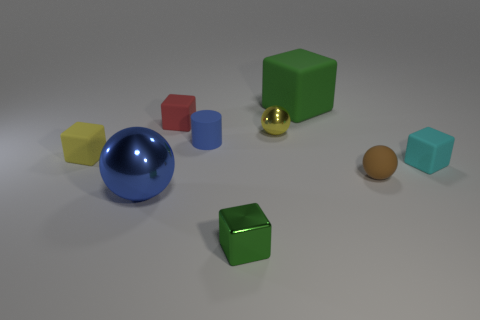What number of cylinders are on the right side of the matte object on the right side of the small brown matte thing?
Ensure brevity in your answer.  0. What number of other things are there of the same shape as the small yellow rubber object?
Make the answer very short. 4. There is a small cylinder that is the same color as the big metal object; what is its material?
Provide a short and direct response. Rubber. How many metal blocks are the same color as the big metallic sphere?
Provide a short and direct response. 0. What color is the cube that is made of the same material as the large blue thing?
Ensure brevity in your answer.  Green. Are there any red objects of the same size as the cylinder?
Give a very brief answer. Yes. Are there more tiny cubes that are to the right of the small cylinder than green metallic cubes that are left of the green metallic object?
Provide a short and direct response. Yes. Are the small yellow thing to the left of the small red thing and the tiny ball behind the blue matte cylinder made of the same material?
Ensure brevity in your answer.  No. There is a yellow rubber object that is the same size as the yellow metal ball; what shape is it?
Keep it short and to the point. Cube. Are there any yellow things of the same shape as the tiny green thing?
Make the answer very short. Yes. 